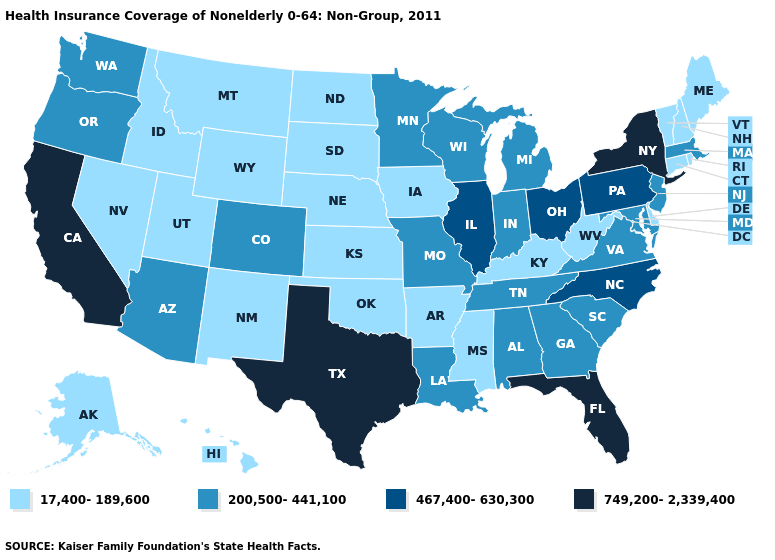How many symbols are there in the legend?
Keep it brief. 4. Does the first symbol in the legend represent the smallest category?
Give a very brief answer. Yes. Name the states that have a value in the range 749,200-2,339,400?
Give a very brief answer. California, Florida, New York, Texas. Name the states that have a value in the range 17,400-189,600?
Keep it brief. Alaska, Arkansas, Connecticut, Delaware, Hawaii, Idaho, Iowa, Kansas, Kentucky, Maine, Mississippi, Montana, Nebraska, Nevada, New Hampshire, New Mexico, North Dakota, Oklahoma, Rhode Island, South Dakota, Utah, Vermont, West Virginia, Wyoming. What is the value of Iowa?
Be succinct. 17,400-189,600. What is the value of Massachusetts?
Short answer required. 200,500-441,100. Does New Hampshire have the same value as Indiana?
Concise answer only. No. Among the states that border Wyoming , does Idaho have the highest value?
Give a very brief answer. No. What is the value of New Hampshire?
Give a very brief answer. 17,400-189,600. What is the value of New Hampshire?
Concise answer only. 17,400-189,600. Does Vermont have a lower value than Georgia?
Answer briefly. Yes. Does the map have missing data?
Give a very brief answer. No. Does Texas have the highest value in the South?
Give a very brief answer. Yes. Does Idaho have the lowest value in the USA?
Give a very brief answer. Yes. Does the first symbol in the legend represent the smallest category?
Give a very brief answer. Yes. 